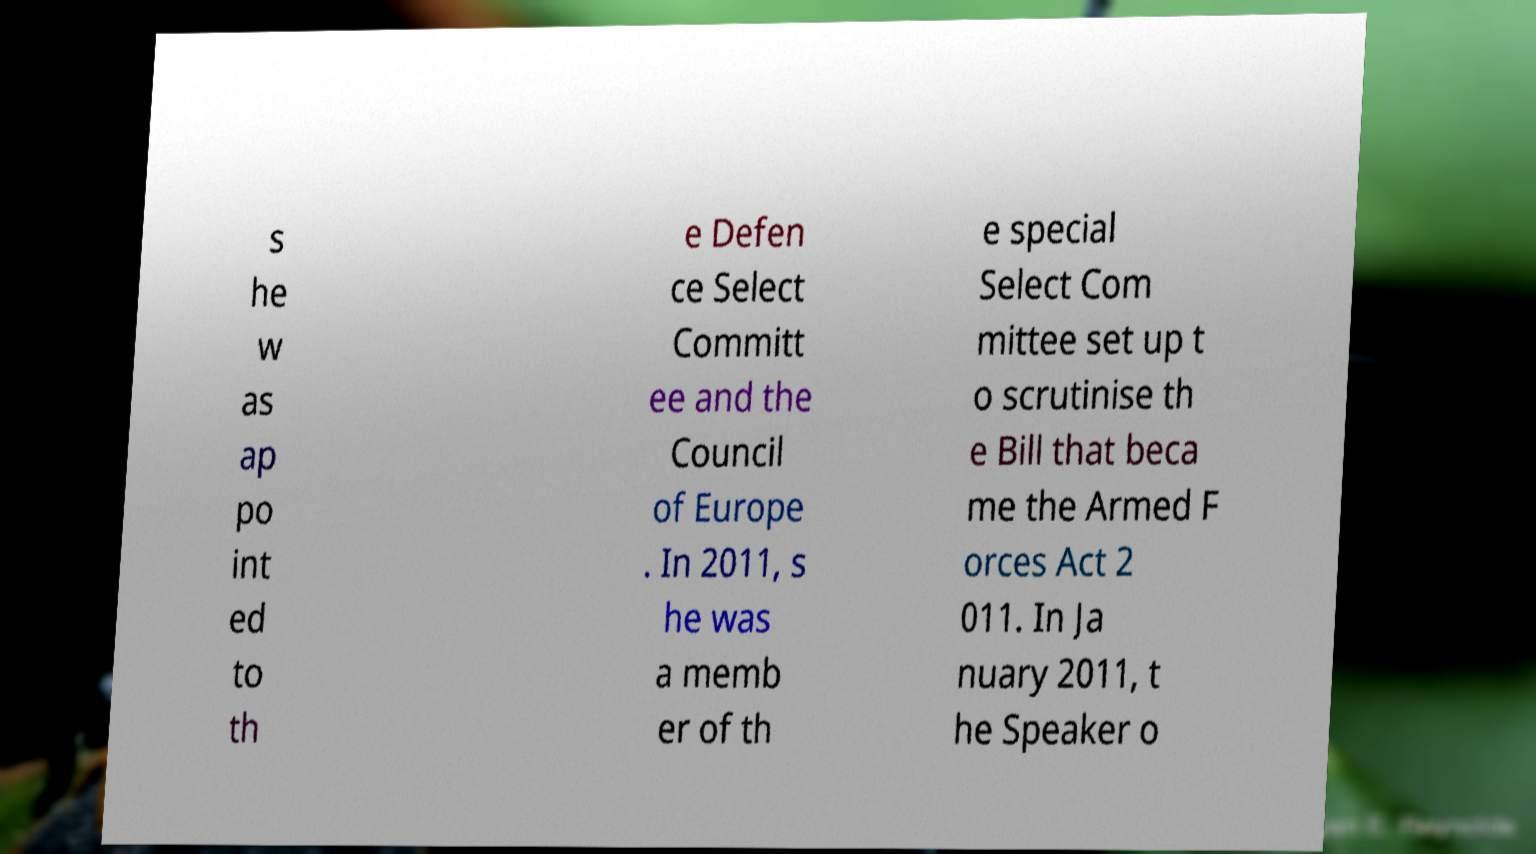What messages or text are displayed in this image? I need them in a readable, typed format. s he w as ap po int ed to th e Defen ce Select Committ ee and the Council of Europe . In 2011, s he was a memb er of th e special Select Com mittee set up t o scrutinise th e Bill that beca me the Armed F orces Act 2 011. In Ja nuary 2011, t he Speaker o 